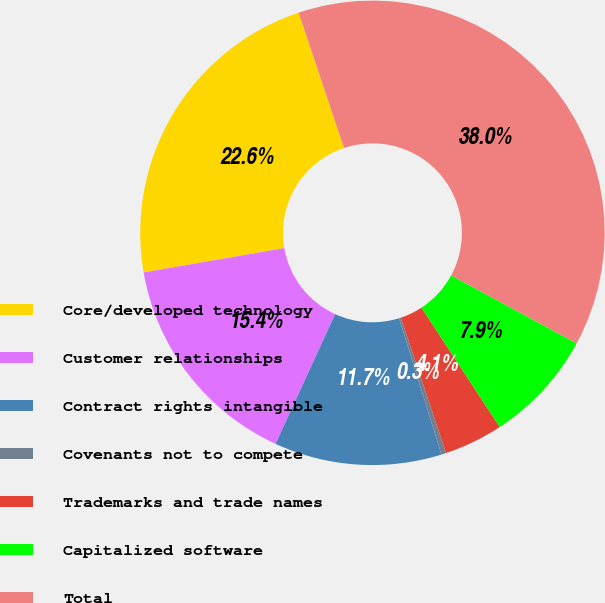Convert chart. <chart><loc_0><loc_0><loc_500><loc_500><pie_chart><fcel>Core/developed technology<fcel>Customer relationships<fcel>Contract rights intangible<fcel>Covenants not to compete<fcel>Trademarks and trade names<fcel>Capitalized software<fcel>Total<nl><fcel>22.58%<fcel>15.42%<fcel>11.65%<fcel>0.33%<fcel>4.1%<fcel>7.87%<fcel>38.04%<nl></chart> 